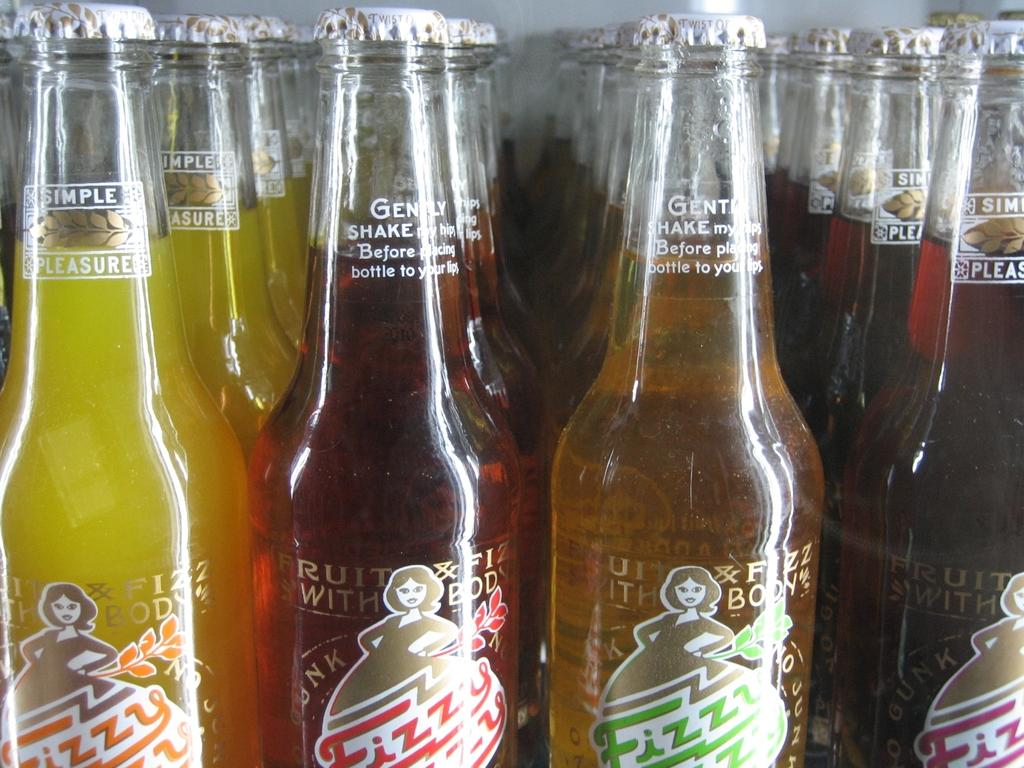<image>
Describe the image concisely. A yellow bottle of soda says "simple pleasure" on the neck. 